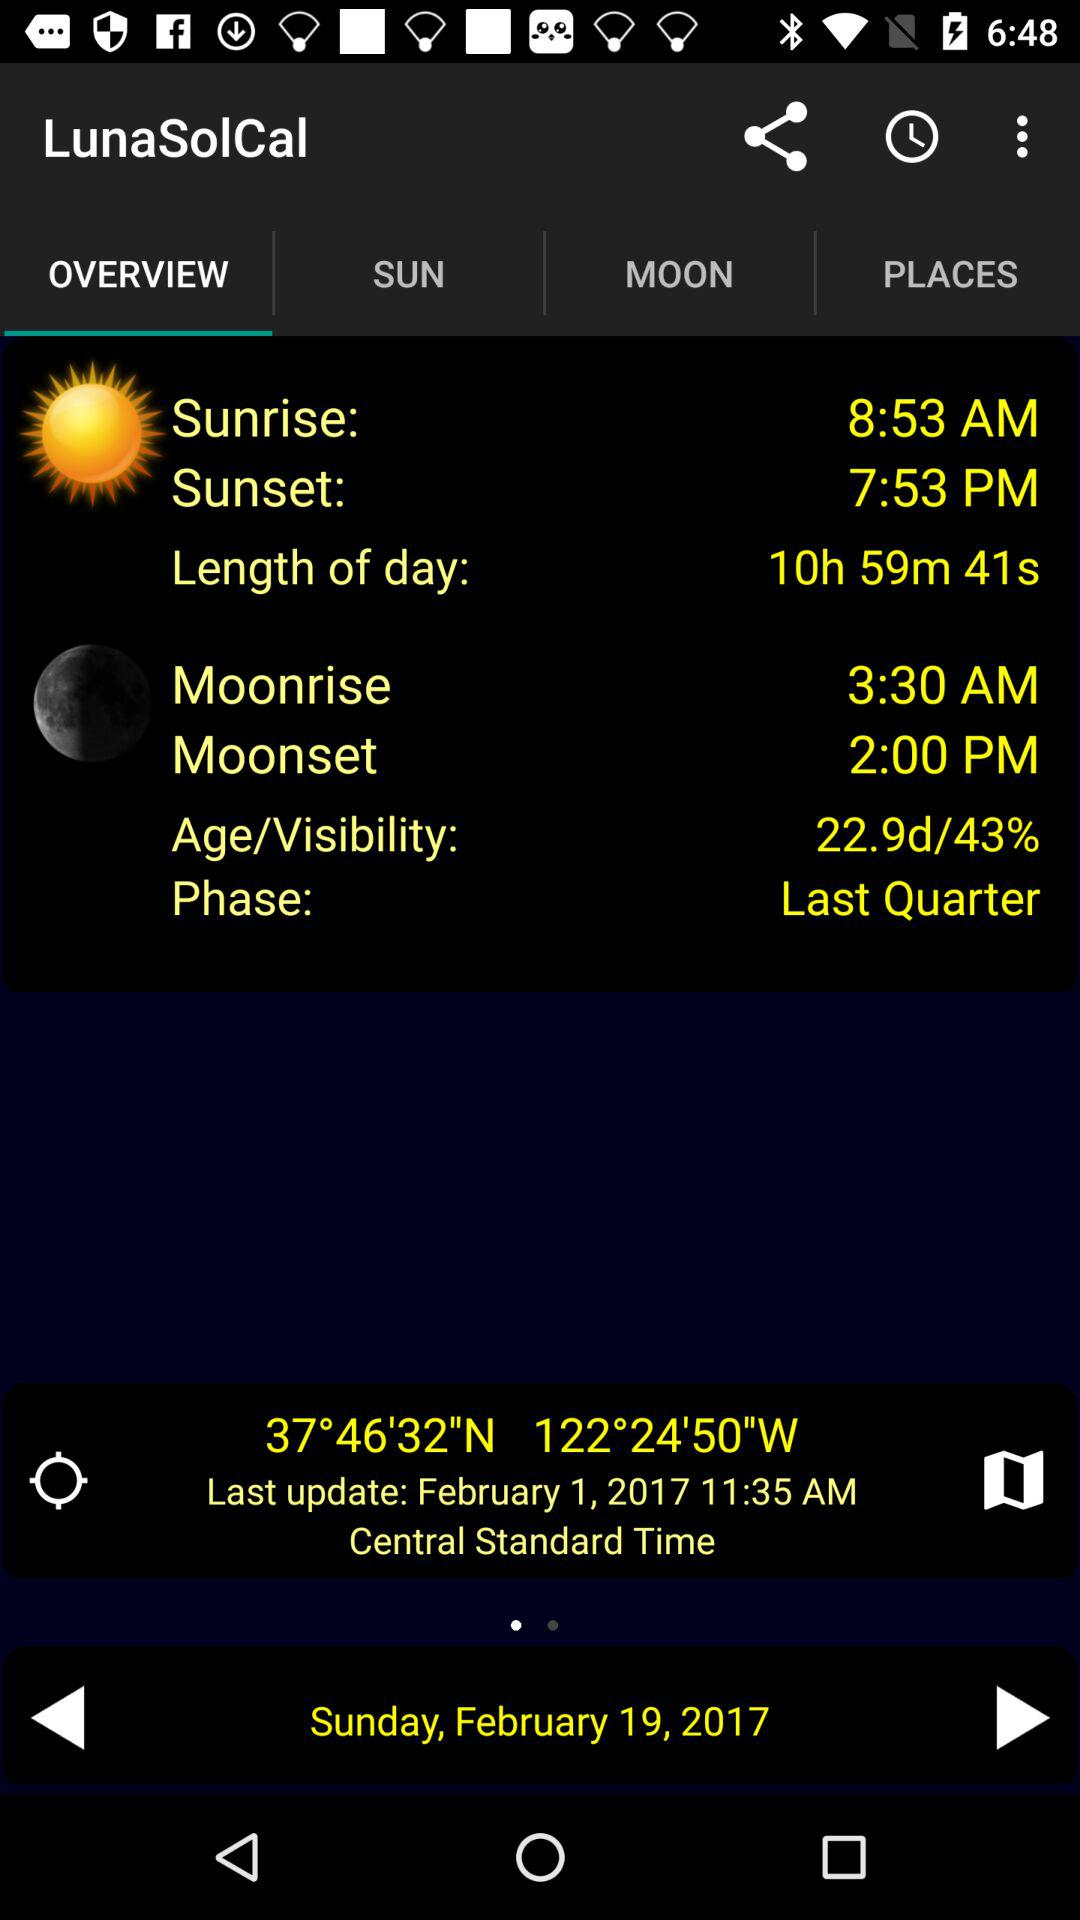At what time is sunrise? The sunrise time is 8:53 AM. 